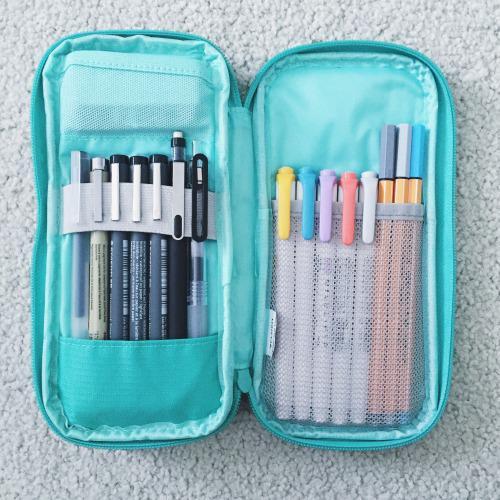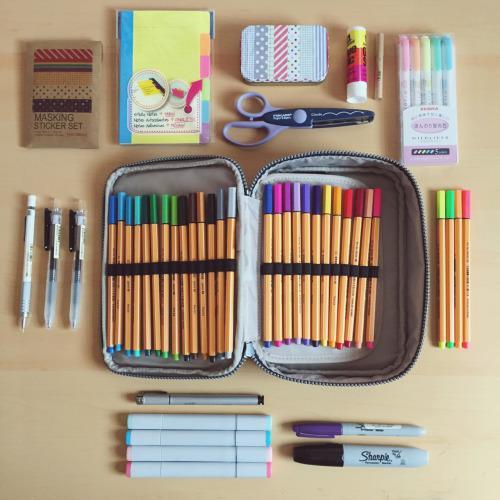The first image is the image on the left, the second image is the image on the right. For the images shown, is this caption "An image shows an opened case flanked by multiple different type implements." true? Answer yes or no. Yes. 